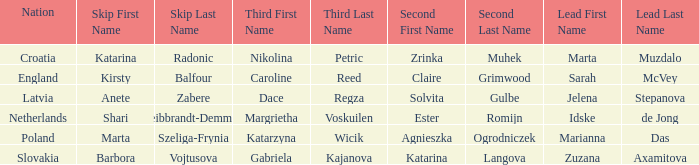What is the name of the second who has Caroline Reed as third? Claire Grimwood. 